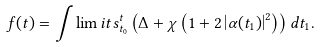<formula> <loc_0><loc_0><loc_500><loc_500>f ( t ) = \int \lim i t s _ { t _ { 0 } } ^ { t } \left ( \Delta + \chi \left ( 1 + 2 \left | \alpha ( t _ { 1 } ) \right | ^ { 2 } \right ) \right ) d t _ { 1 } .</formula> 